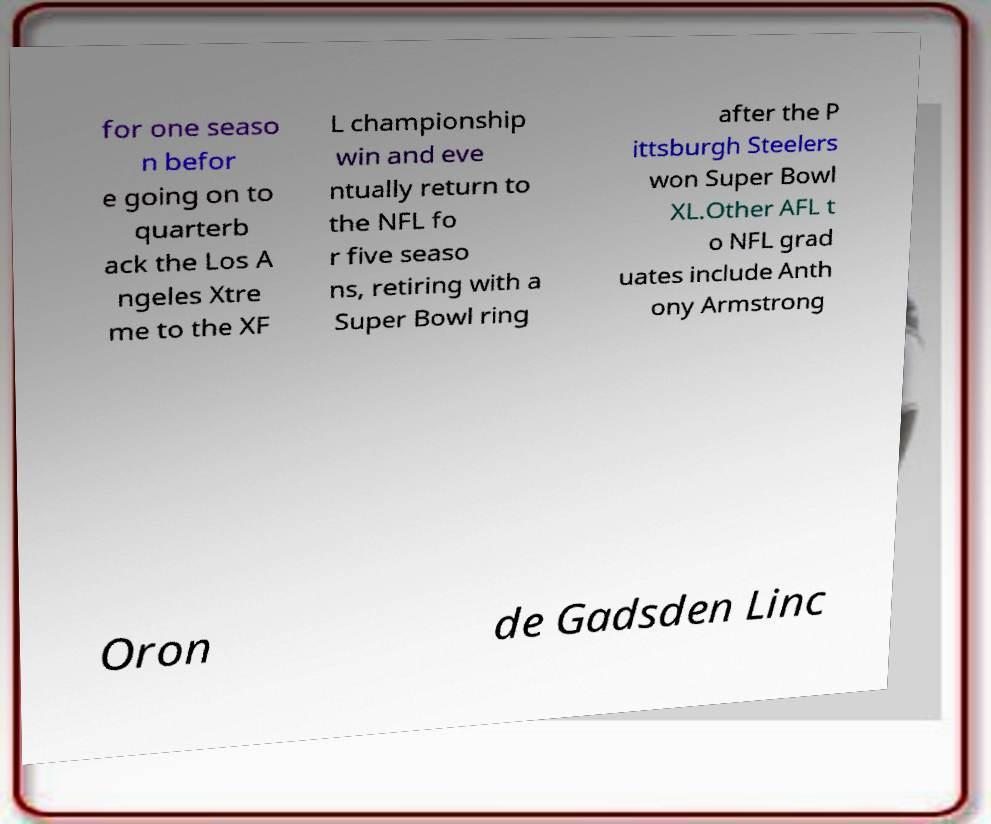Can you accurately transcribe the text from the provided image for me? for one seaso n befor e going on to quarterb ack the Los A ngeles Xtre me to the XF L championship win and eve ntually return to the NFL fo r five seaso ns, retiring with a Super Bowl ring after the P ittsburgh Steelers won Super Bowl XL.Other AFL t o NFL grad uates include Anth ony Armstrong Oron de Gadsden Linc 